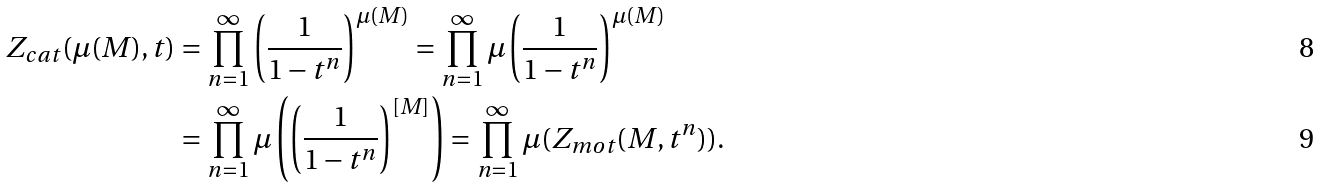Convert formula to latex. <formula><loc_0><loc_0><loc_500><loc_500>Z _ { c a t } ( \mu ( M ) , t ) & = \prod _ { n = 1 } ^ { \infty } \left ( \frac { 1 } { 1 - t ^ { n } } \right ) ^ { \mu ( M ) } = \prod _ { n = 1 } ^ { \infty } \mu \left ( \frac { 1 } { 1 - t ^ { n } } \right ) ^ { \mu ( M ) } \\ & = \prod _ { n = 1 } ^ { \infty } \mu \left ( \left ( \frac { 1 } { 1 - t ^ { n } } \right ) ^ { [ M ] } \right ) = \prod _ { n = 1 } ^ { \infty } \mu ( Z _ { m o t } ( M , t ^ { n } ) ) .</formula> 